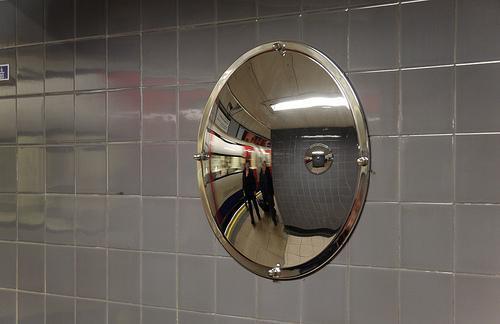How many people are in the reflection?
Give a very brief answer. 2. 